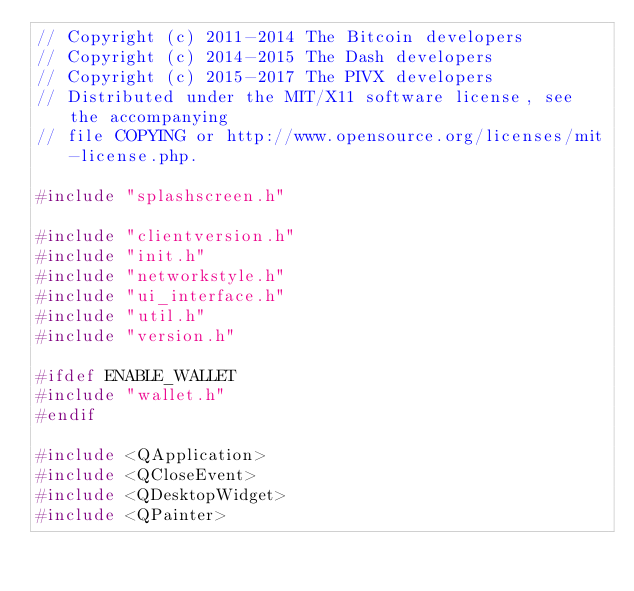<code> <loc_0><loc_0><loc_500><loc_500><_C++_>// Copyright (c) 2011-2014 The Bitcoin developers
// Copyright (c) 2014-2015 The Dash developers
// Copyright (c) 2015-2017 The PIVX developers
// Distributed under the MIT/X11 software license, see the accompanying
// file COPYING or http://www.opensource.org/licenses/mit-license.php.

#include "splashscreen.h"

#include "clientversion.h"
#include "init.h"
#include "networkstyle.h"
#include "ui_interface.h"
#include "util.h"
#include "version.h"

#ifdef ENABLE_WALLET
#include "wallet.h"
#endif

#include <QApplication>
#include <QCloseEvent>
#include <QDesktopWidget>
#include <QPainter>
</code> 